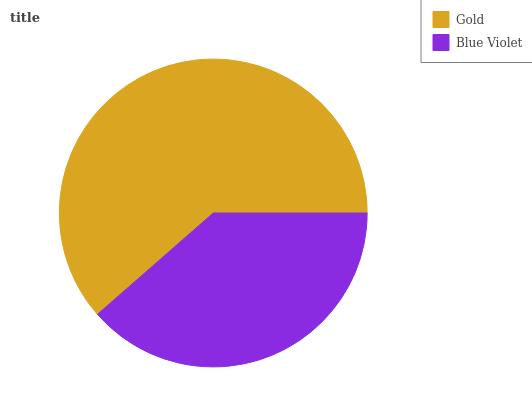Is Blue Violet the minimum?
Answer yes or no. Yes. Is Gold the maximum?
Answer yes or no. Yes. Is Blue Violet the maximum?
Answer yes or no. No. Is Gold greater than Blue Violet?
Answer yes or no. Yes. Is Blue Violet less than Gold?
Answer yes or no. Yes. Is Blue Violet greater than Gold?
Answer yes or no. No. Is Gold less than Blue Violet?
Answer yes or no. No. Is Gold the high median?
Answer yes or no. Yes. Is Blue Violet the low median?
Answer yes or no. Yes. Is Blue Violet the high median?
Answer yes or no. No. Is Gold the low median?
Answer yes or no. No. 